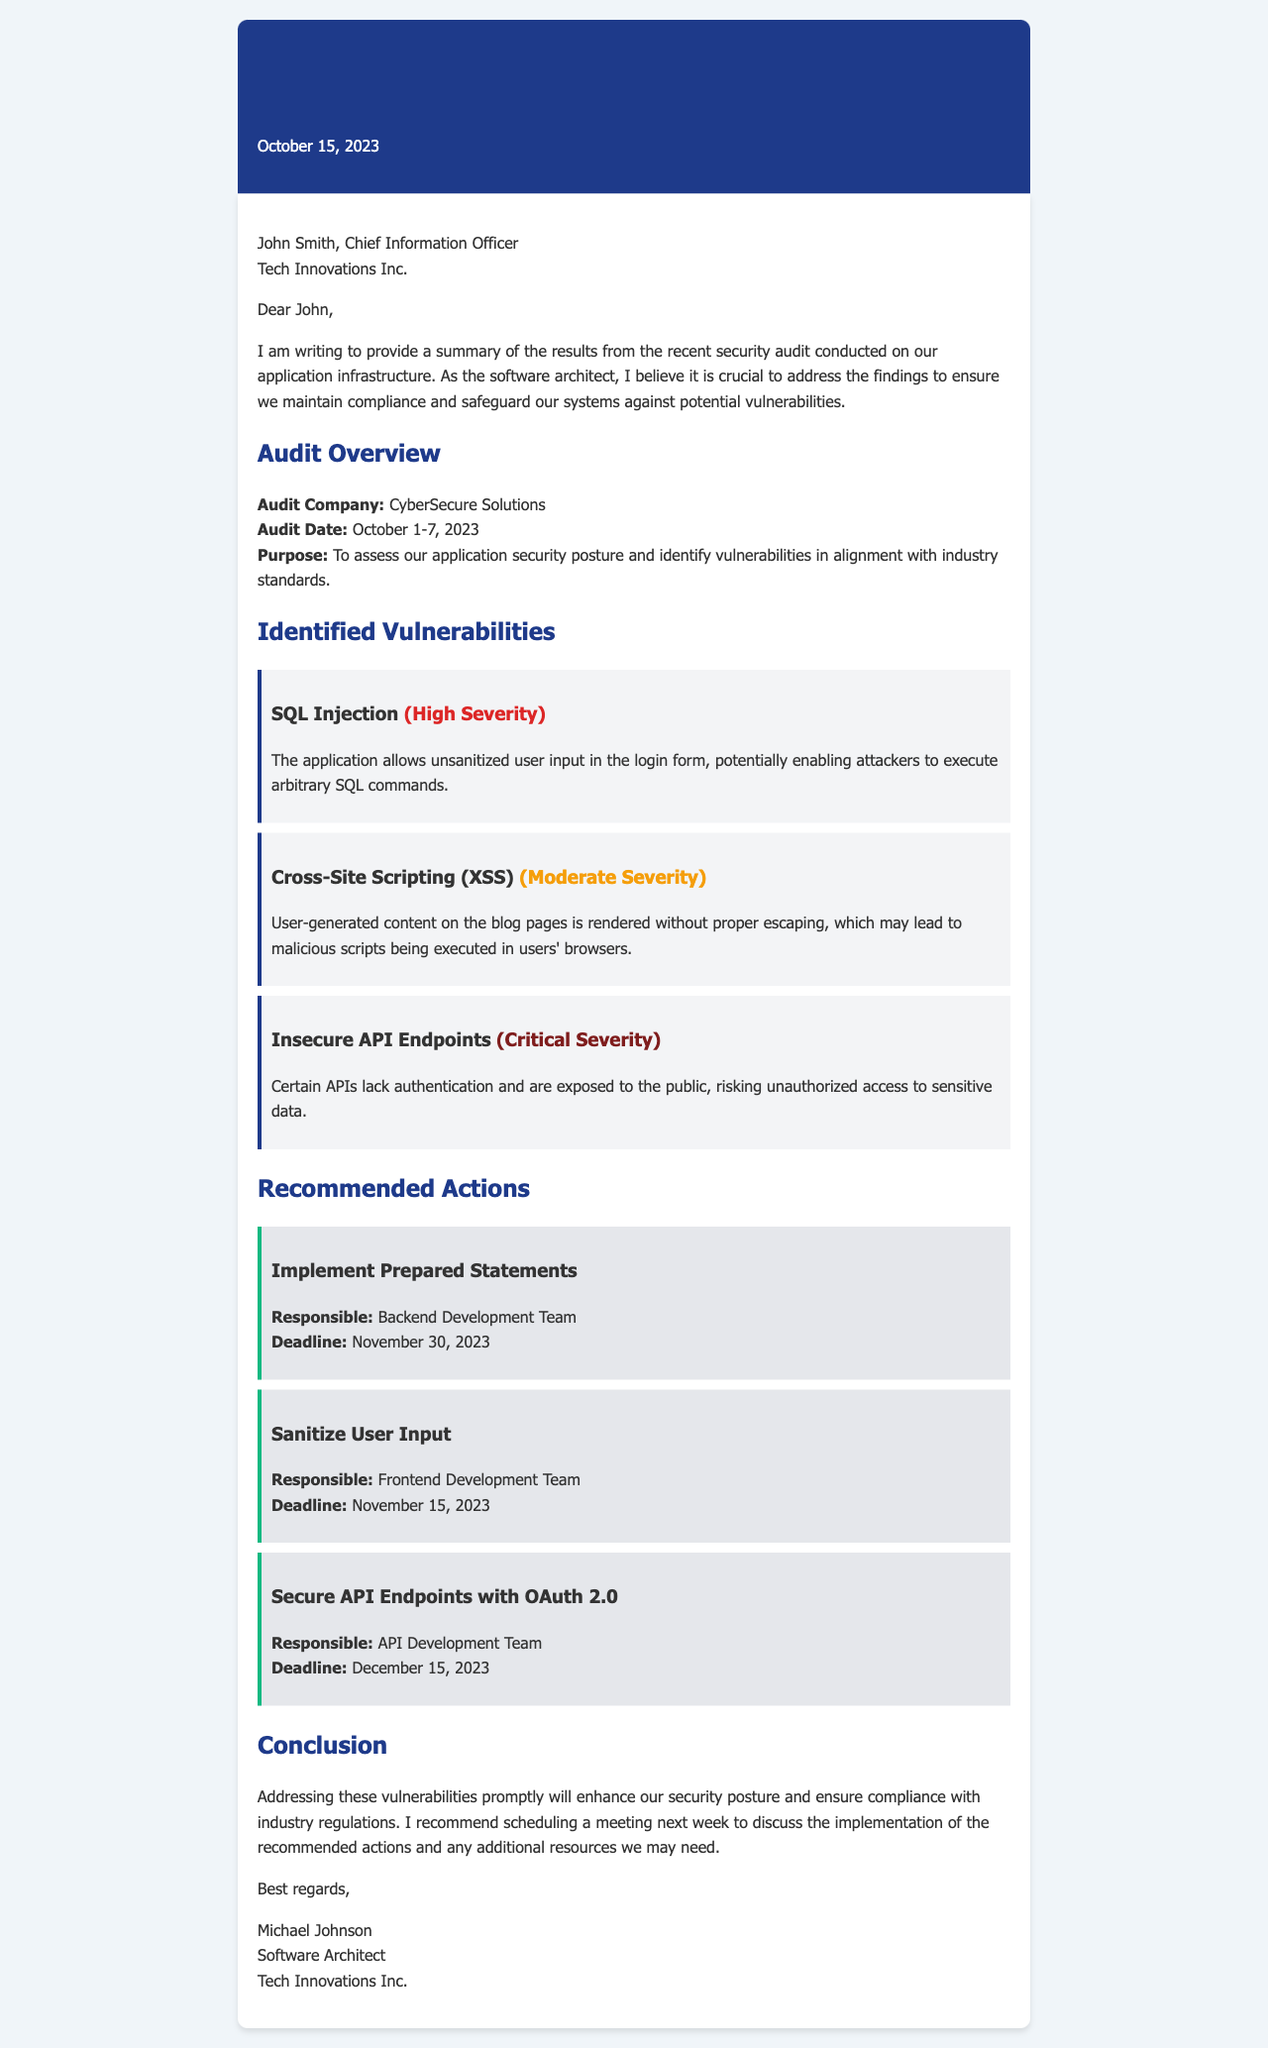What is the audit date range? The audit date range is specified as October 1-7, 2023, in the audit overview section.
Answer: October 1-7, 2023 Who conducted the security audit? The audit company mentioned in the document is CyberSecure Solutions, noted in the audit overview section.
Answer: CyberSecure Solutions What is the severity level of SQL Injection? The document categorizes SQL Injection as a "High Severity" vulnerability in the identified vulnerabilities section.
Answer: High Severity By when should the user input sanitation be completed? The deadline for sanitizing user input is mentioned in the recommended actions section as November 15, 2023.
Answer: November 15, 2023 What is one recommended action for the API Development Team? The document states that a recommended action for the API Development Team is to "Secure API Endpoints with OAuth 2.0".
Answer: Secure API Endpoints with OAuth 2.0 What role does Michael Johnson hold? The document identifies Michael Johnson's role as the Software Architect at Tech Innovations Inc. in the closing section.
Answer: Software Architect How many vulnerabilities are identified? There are three vulnerabilities listed in the identified vulnerabilities section of the document.
Answer: Three What is the purpose of the audit? The document states that the purpose of the audit is to assess the application security posture and identify vulnerabilities in alignment with industry standards.
Answer: To assess our application security posture and identify vulnerabilities in alignment with industry standards What is the suggested follow-up action after addressing the vulnerabilities? The document recommends scheduling a meeting next week to discuss the implementation of the recommended actions.
Answer: Schedule a meeting next week to discuss the implementation 